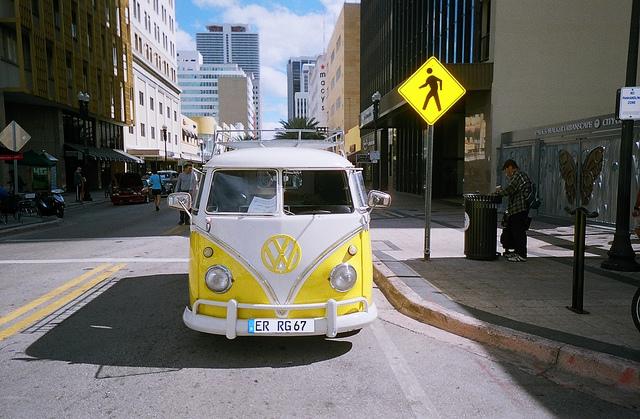What color is the trash can?
Answer briefly. Black. Is the color of the van factory supplied?
Keep it brief. Yes. What company made the van?
Answer briefly. Volkswagen. What does the yellow sign indicate?
Keep it brief. Pedestrian crossing. 